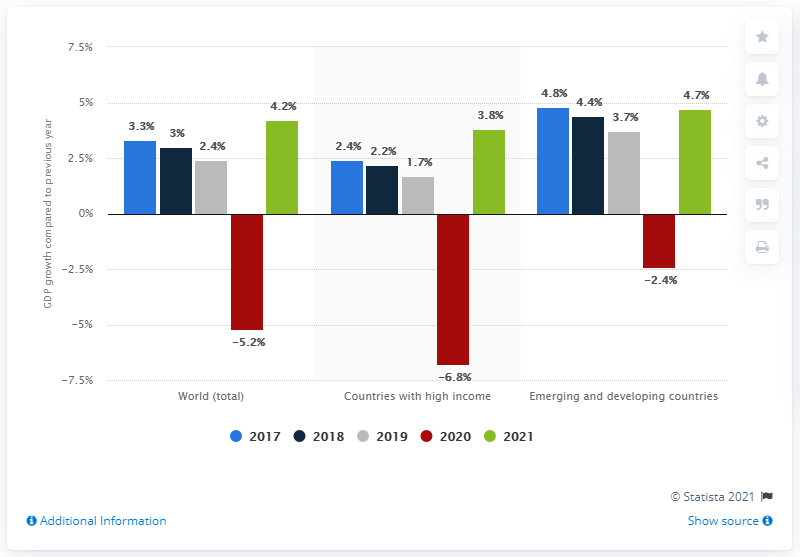Give some essential details in this illustration. According to the forecast, the economic growth of emerging and developing countries is expected to reach 4.7% in 2021. 